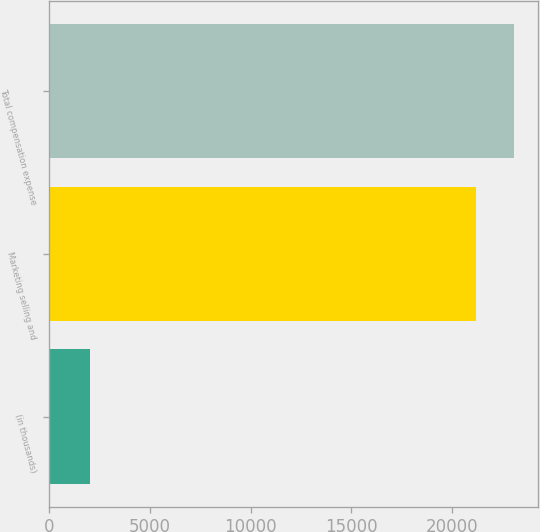Convert chart to OTSL. <chart><loc_0><loc_0><loc_500><loc_500><bar_chart><fcel>(in thousands)<fcel>Marketing selling and<fcel>Total compensation expense<nl><fcel>2013<fcel>21178<fcel>23094.5<nl></chart> 